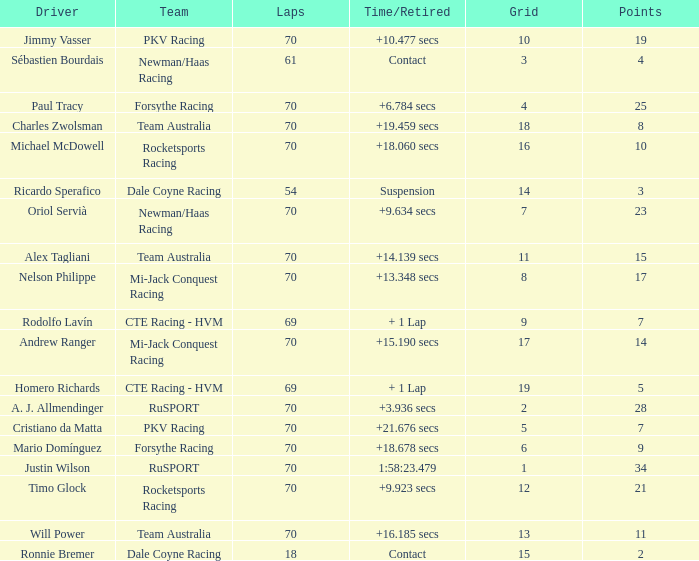Who scored with a grid of 10 and the highest amount of laps? 70.0. 